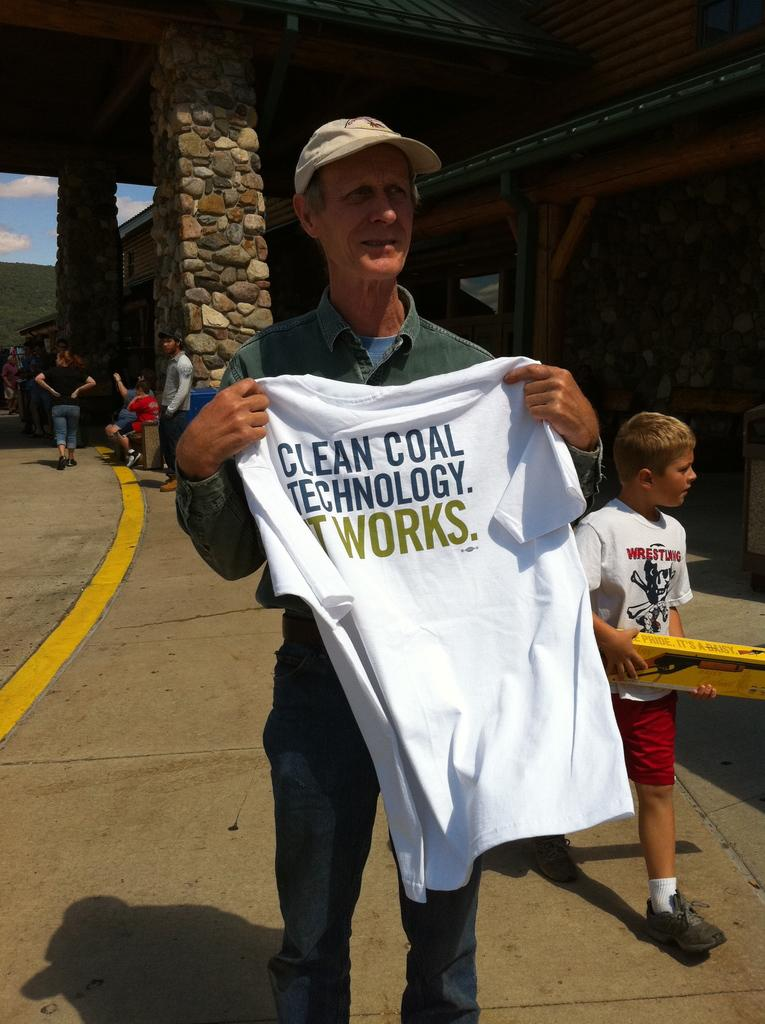<image>
Give a short and clear explanation of the subsequent image. A man holds a Tee shirt proclaiming that Clean Coal technology works 